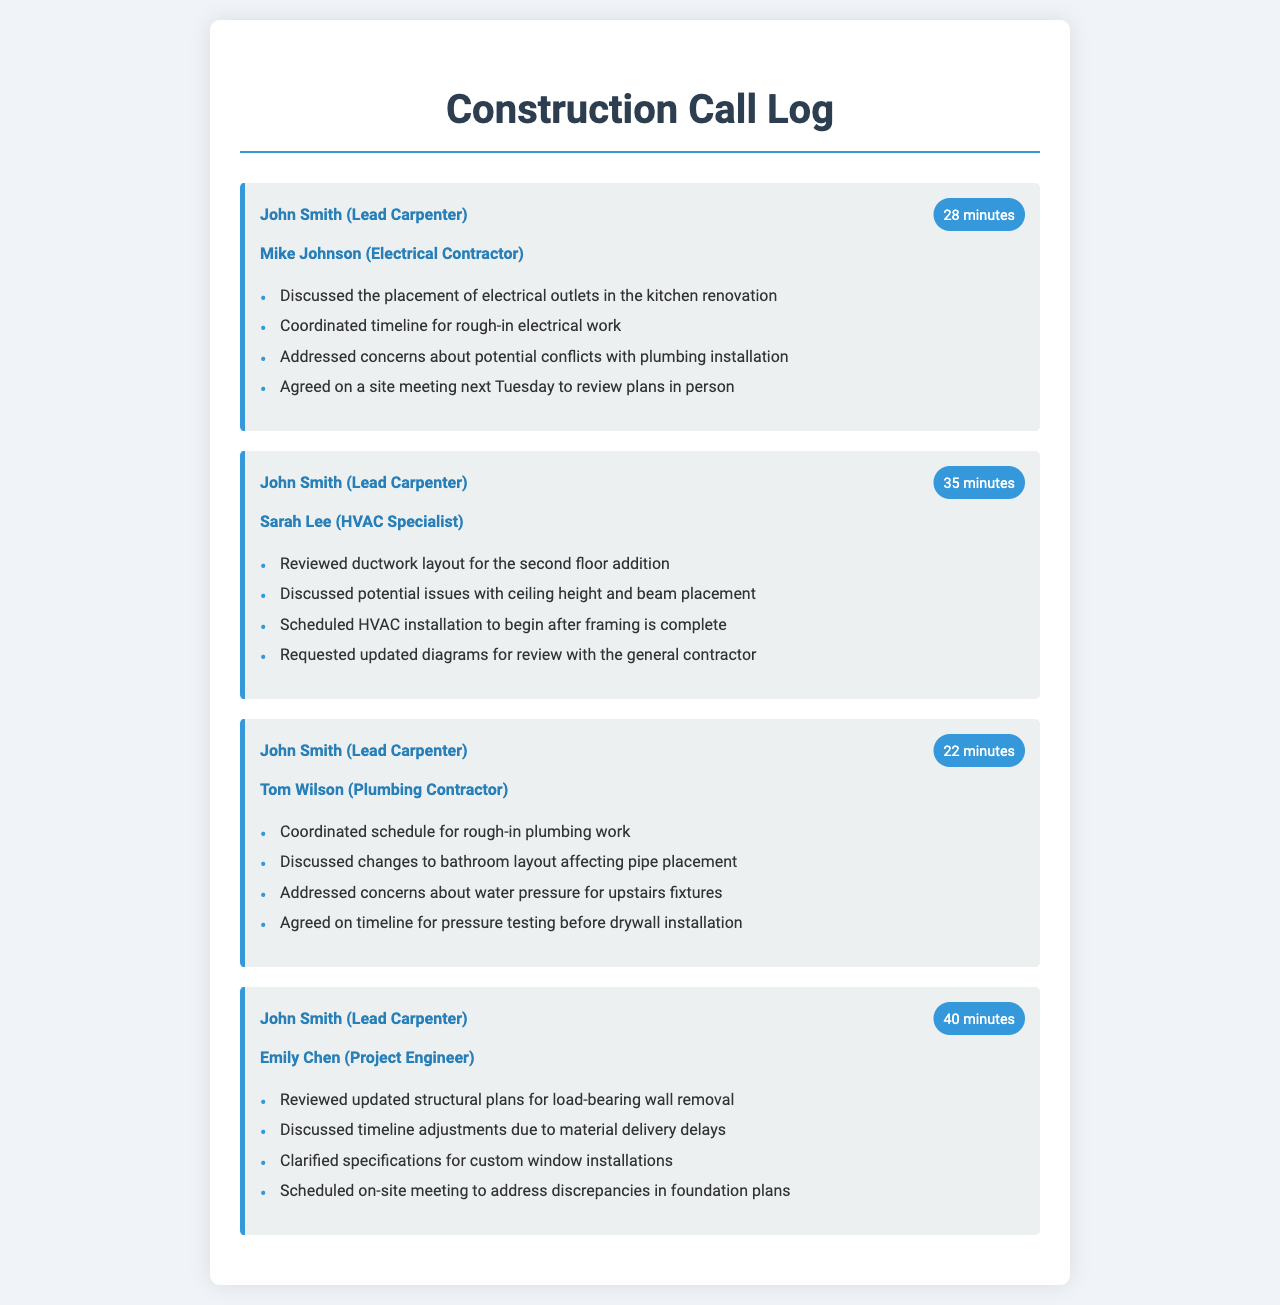What is the duration of the call with Mike Johnson? The duration of the call is mentioned in the document next to Mike Johnson's name.
Answer: 28 minutes Who is the recipient of the call regarding the HVAC installation? The recipient's name for the HVAC installation discussions is directly stated under the call record.
Answer: Sarah Lee What was discussed about the kitchen renovation in the call with Mike Johnson? The specific topic mentioned in the call with Mike Johnson regarding the kitchen renovation is listed in the call notes.
Answer: Placement of electrical outlets How long was the call with Emily Chen? The duration is explicitly stated in the document accompanying her name.
Answer: 40 minutes What was scheduled to happen after framing is complete? The call record lists the planned work in relation to the framing schedule under Sarah Lee's discussion.
Answer: HVAC installation What issue was addressed concerning upstairs fixtures? The concerns mentioned during the call with Tom Wilson detail the problem affecting the upstairs fixtures.
Answer: Water pressure What did John Smith request during the call with Sarah Lee? The request is explicitly detailed in the call notes for the conversation with Sarah Lee.
Answer: Updated diagrams What was agreed upon regarding the plumbing timeline? The timeline arrangements discussed in the call with Tom Wilson are directly mentioned in the summarized notes.
Answer: Timeline for pressure testing before drywall installation 